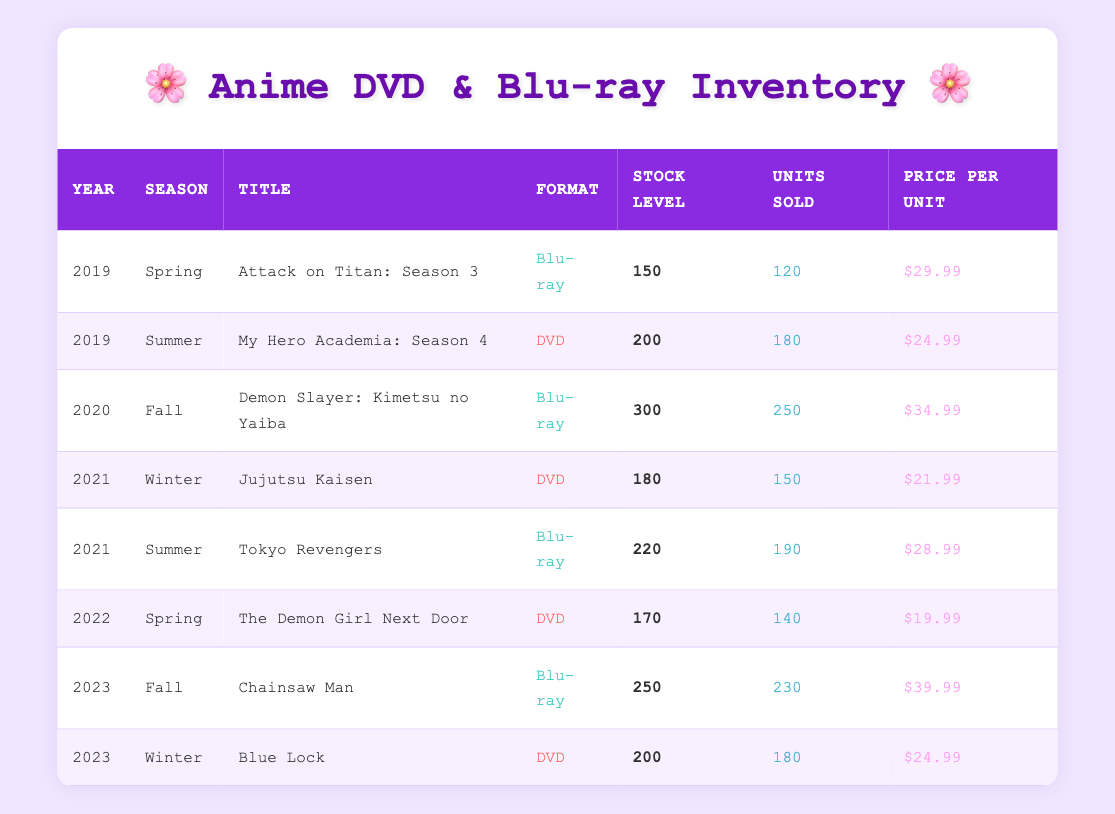What was the stock level of "Tokyo Revengers" in 2021? The table shows a row for "Tokyo Revengers" under 2021 for the Summer season. The stock level column indicates a stock level of 220.
Answer: 220 Which anime had the highest units sold in 2023? In 2023, "Chainsaw Man" sold 230 units while "Blue Lock" sold 180 units. Therefore, "Chainsaw Man" had the highest units sold in that year.
Answer: Chainsaw Man What is the average price per unit for DVDs listed in the table? The DVDs listed are "My Hero Academia: Season 4" ($24.99), "Jujutsu Kaisen" ($21.99), "The Demon Girl Next Door" ($19.99), and "Blue Lock" ($24.99), totaling $91.96. Dividing by 4 gives an average of $22.99.
Answer: 22.99 Was the stock level for "Attack on Titan: Season 3" greater than that for "Demon Slayer: Kimetsu no Yaiba"? The stock level for "Attack on Titan: Season 3" is 150 and for "Demon Slayer: Kimetsu no Yaiba" is 300. Since 150 is less than 300, the statement is false.
Answer: No Which season in 2022 had the least units sold? The only entry for 2022 is "The Demon Girl Next Door" which had 140 units sold in Spring. Since there were no other entries, this must be the least.
Answer: Spring 2022 